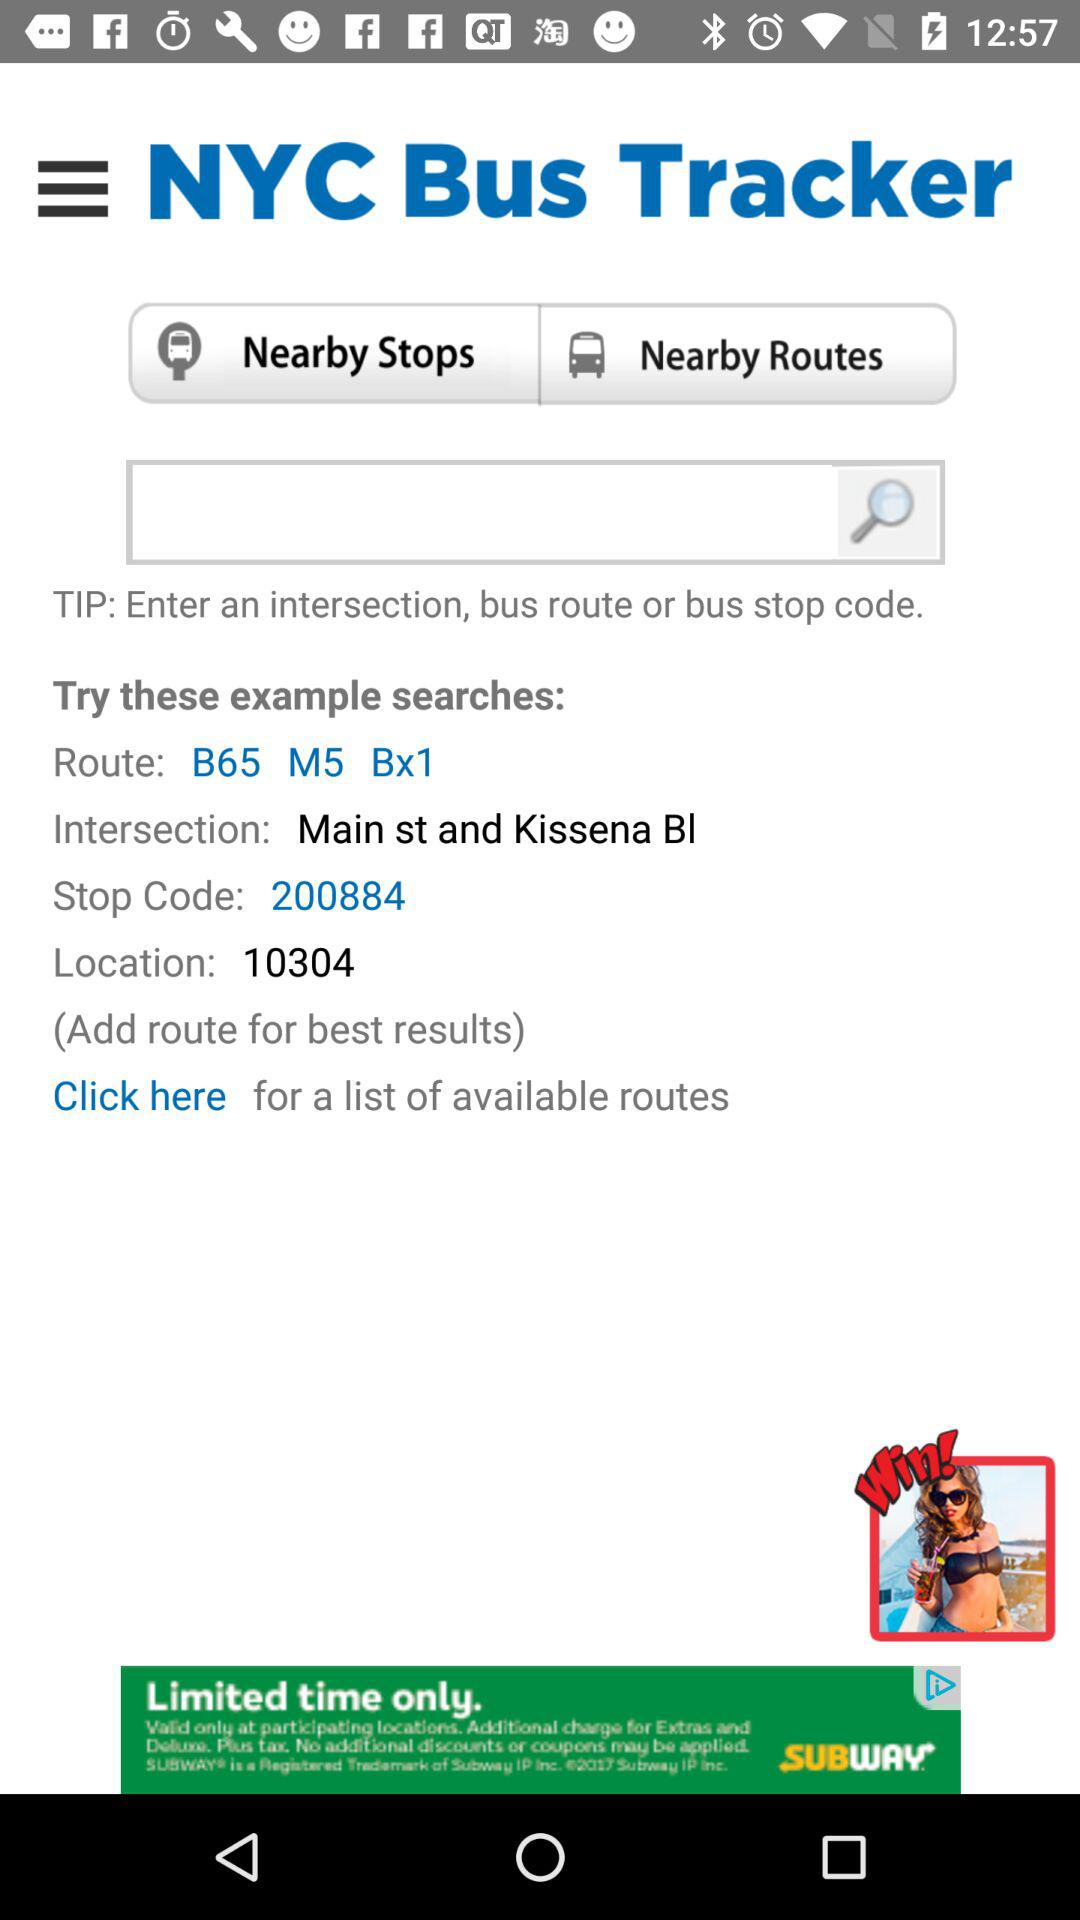What is the location code? The location code is 10304. 